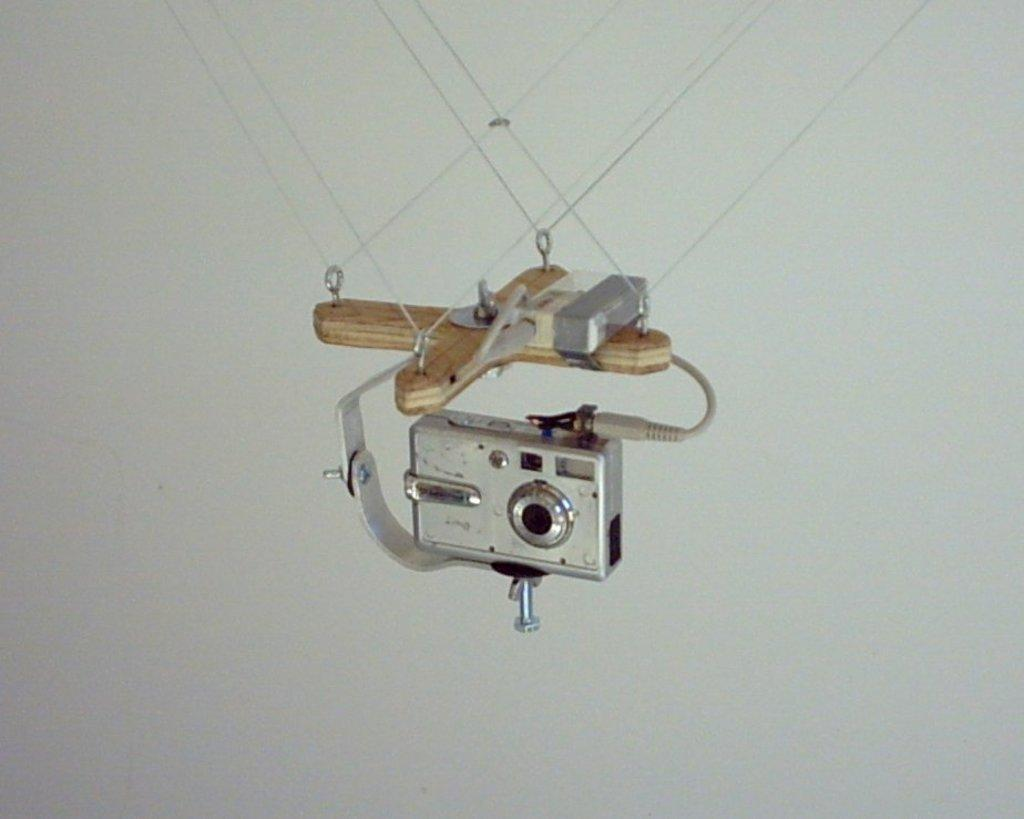What is the main object in the image? There is a camera in the image. How is the camera positioned or supported? The camera has a stand. Are there any additional details about the stand? The stand is tied with some threads. What can be seen in the background of the image? There is a wall visible in the image. What type of pen is being used to write on the wall in the image? There is no pen or writing on the wall in the image; it only features a camera with a stand. 